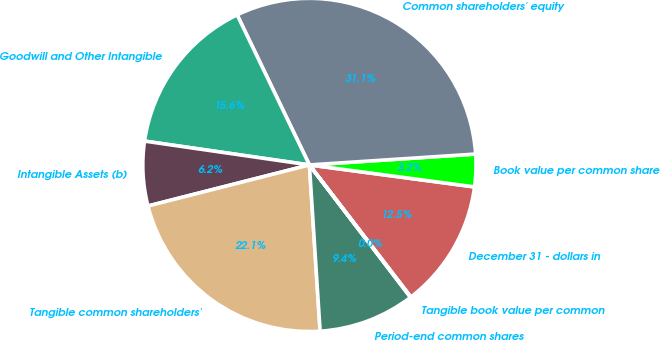Convert chart. <chart><loc_0><loc_0><loc_500><loc_500><pie_chart><fcel>December 31 - dollars in<fcel>Book value per common share<fcel>Common shareholders' equity<fcel>Goodwill and Other Intangible<fcel>Intangible Assets (b)<fcel>Tangible common shareholders'<fcel>Period-end common shares<fcel>Tangible book value per common<nl><fcel>12.47%<fcel>3.15%<fcel>31.1%<fcel>15.57%<fcel>6.25%<fcel>22.06%<fcel>9.36%<fcel>0.04%<nl></chart> 